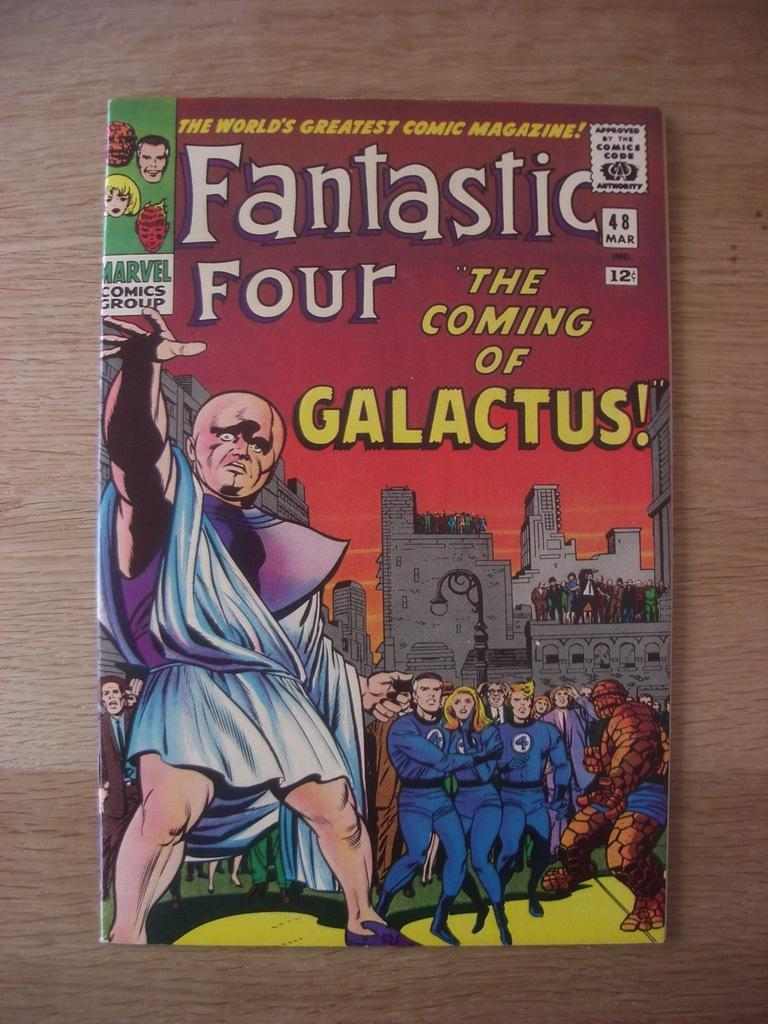<image>
Render a clear and concise summary of the photo. Fantastic four the coming of galactus magazine on a table 